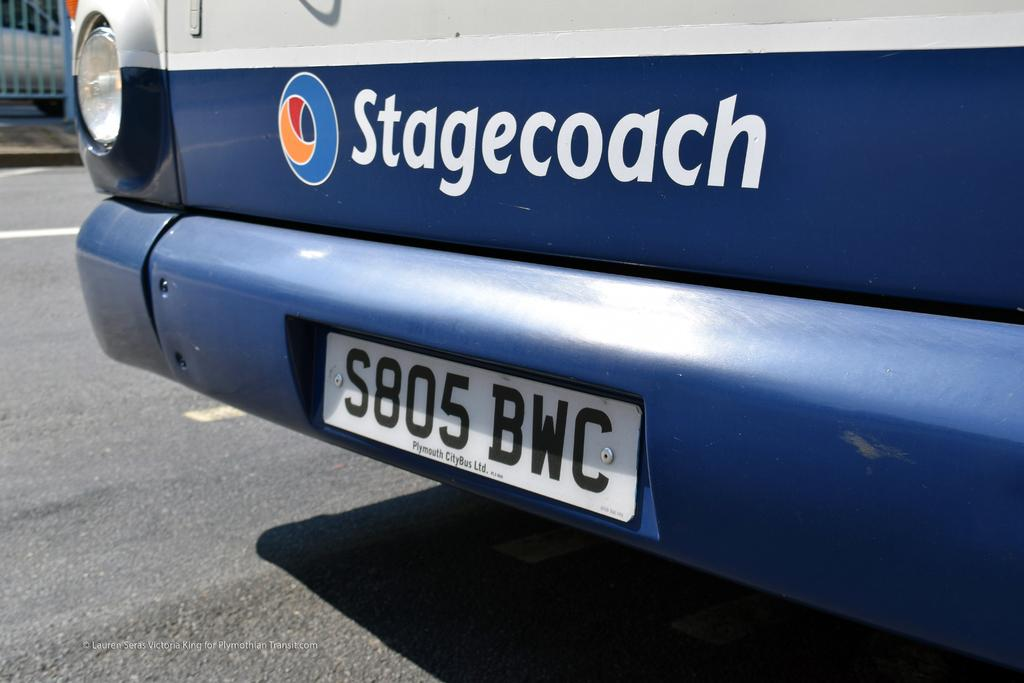<image>
Offer a succinct explanation of the picture presented. a stagecoach ad on the back of a car 